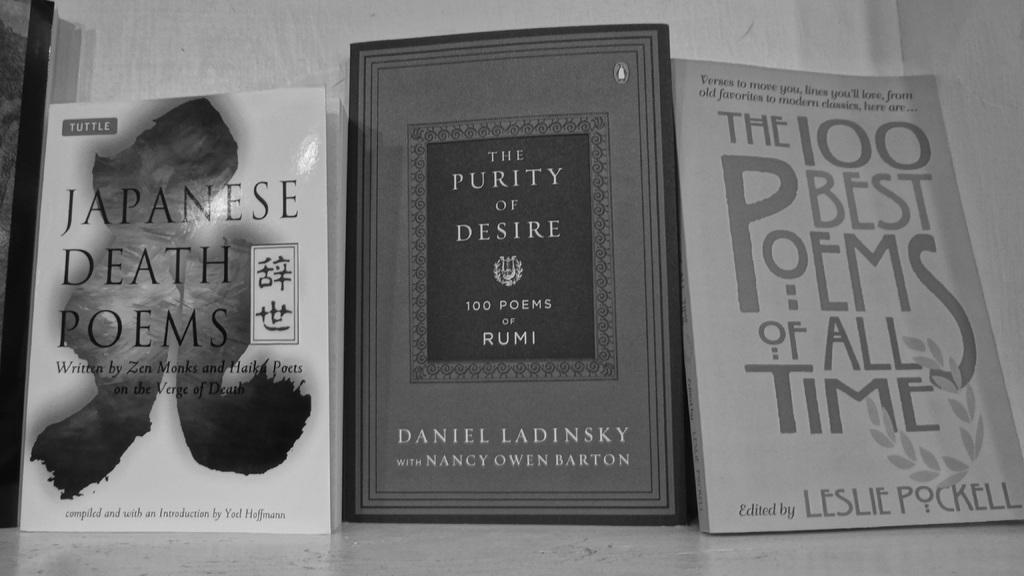<image>
Relay a brief, clear account of the picture shown. Three books on Poetry sit side by side, one contains the 100 best poems of all time. 